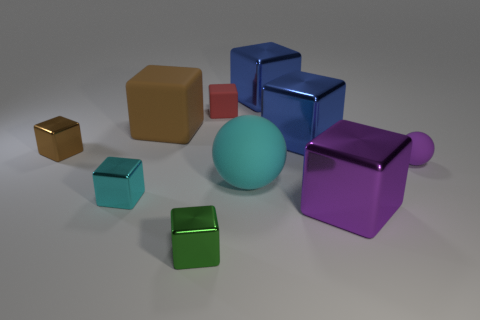Does the big metallic object that is behind the brown rubber block have the same shape as the metallic object that is in front of the large purple metallic object?
Provide a succinct answer. Yes. Are there any blocks to the left of the small green thing?
Your response must be concise. Yes. The other matte thing that is the same shape as the tiny purple matte thing is what color?
Give a very brief answer. Cyan. What is the cyan object to the left of the green metallic cube made of?
Offer a very short reply. Metal. What size is the purple object that is the same shape as the red rubber thing?
Make the answer very short. Large. What number of brown things are made of the same material as the tiny green block?
Your response must be concise. 1. How many metallic things are the same color as the big matte cube?
Offer a very short reply. 1. What number of things are big cubes on the left side of the big purple cube or cubes that are right of the tiny brown metallic object?
Offer a very short reply. 7. Are there fewer cyan matte balls on the left side of the cyan shiny object than purple blocks?
Offer a very short reply. Yes. Are there any purple matte things of the same size as the purple cube?
Offer a very short reply. No. 